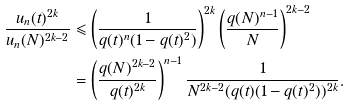Convert formula to latex. <formula><loc_0><loc_0><loc_500><loc_500>\frac { u _ { n } ( t ) ^ { 2 k } } { u _ { n } ( N ) ^ { 2 k - 2 } } & \leqslant \left ( \frac { 1 } { q ( t ) ^ { n } ( 1 - q ( t ) ^ { 2 } ) } \right ) ^ { 2 k } \left ( \frac { q ( N ) ^ { n - 1 } } { N } \right ) ^ { 2 k - 2 } \\ & = \left ( \frac { q ( N ) ^ { 2 k - 2 } } { q ( t ) ^ { 2 k } } \right ) ^ { n - 1 } \frac { 1 } { N ^ { 2 k - 2 } ( q ( t ) ( 1 - q ( t ) ^ { 2 } ) ) ^ { 2 k } } .</formula> 